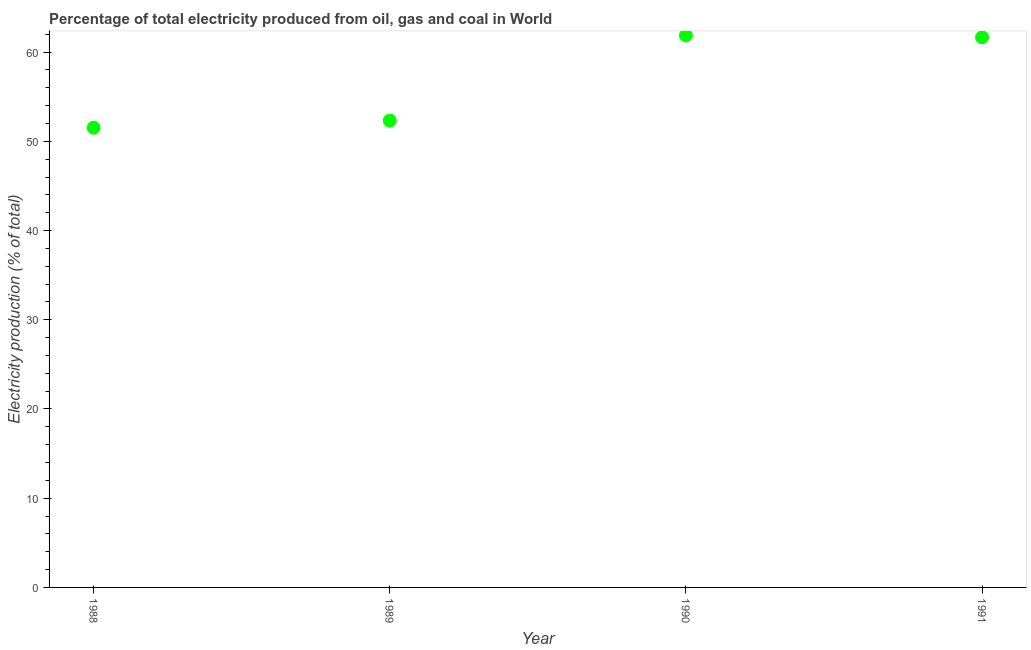What is the electricity production in 1991?
Ensure brevity in your answer.  61.67. Across all years, what is the maximum electricity production?
Make the answer very short. 61.87. Across all years, what is the minimum electricity production?
Ensure brevity in your answer.  51.53. In which year was the electricity production maximum?
Your response must be concise. 1990. What is the sum of the electricity production?
Ensure brevity in your answer.  227.4. What is the difference between the electricity production in 1988 and 1989?
Give a very brief answer. -0.8. What is the average electricity production per year?
Your answer should be very brief. 56.85. What is the median electricity production?
Offer a terse response. 57. In how many years, is the electricity production greater than 34 %?
Your response must be concise. 4. Do a majority of the years between 1988 and 1989 (inclusive) have electricity production greater than 42 %?
Offer a terse response. Yes. What is the ratio of the electricity production in 1989 to that in 1991?
Provide a short and direct response. 0.85. Is the electricity production in 1989 less than that in 1990?
Provide a short and direct response. Yes. What is the difference between the highest and the second highest electricity production?
Make the answer very short. 0.2. Is the sum of the electricity production in 1988 and 1990 greater than the maximum electricity production across all years?
Keep it short and to the point. Yes. What is the difference between the highest and the lowest electricity production?
Your answer should be very brief. 10.34. What is the difference between two consecutive major ticks on the Y-axis?
Your answer should be compact. 10. Does the graph contain any zero values?
Offer a terse response. No. What is the title of the graph?
Your response must be concise. Percentage of total electricity produced from oil, gas and coal in World. What is the label or title of the Y-axis?
Your answer should be very brief. Electricity production (% of total). What is the Electricity production (% of total) in 1988?
Offer a terse response. 51.53. What is the Electricity production (% of total) in 1989?
Offer a very short reply. 52.33. What is the Electricity production (% of total) in 1990?
Keep it short and to the point. 61.87. What is the Electricity production (% of total) in 1991?
Offer a terse response. 61.67. What is the difference between the Electricity production (% of total) in 1988 and 1989?
Provide a short and direct response. -0.8. What is the difference between the Electricity production (% of total) in 1988 and 1990?
Provide a short and direct response. -10.34. What is the difference between the Electricity production (% of total) in 1988 and 1991?
Keep it short and to the point. -10.14. What is the difference between the Electricity production (% of total) in 1989 and 1990?
Ensure brevity in your answer.  -9.54. What is the difference between the Electricity production (% of total) in 1989 and 1991?
Offer a terse response. -9.34. What is the difference between the Electricity production (% of total) in 1990 and 1991?
Your answer should be compact. 0.2. What is the ratio of the Electricity production (% of total) in 1988 to that in 1989?
Provide a short and direct response. 0.98. What is the ratio of the Electricity production (% of total) in 1988 to that in 1990?
Ensure brevity in your answer.  0.83. What is the ratio of the Electricity production (% of total) in 1988 to that in 1991?
Your response must be concise. 0.84. What is the ratio of the Electricity production (% of total) in 1989 to that in 1990?
Provide a short and direct response. 0.85. What is the ratio of the Electricity production (% of total) in 1989 to that in 1991?
Give a very brief answer. 0.85. What is the ratio of the Electricity production (% of total) in 1990 to that in 1991?
Keep it short and to the point. 1. 